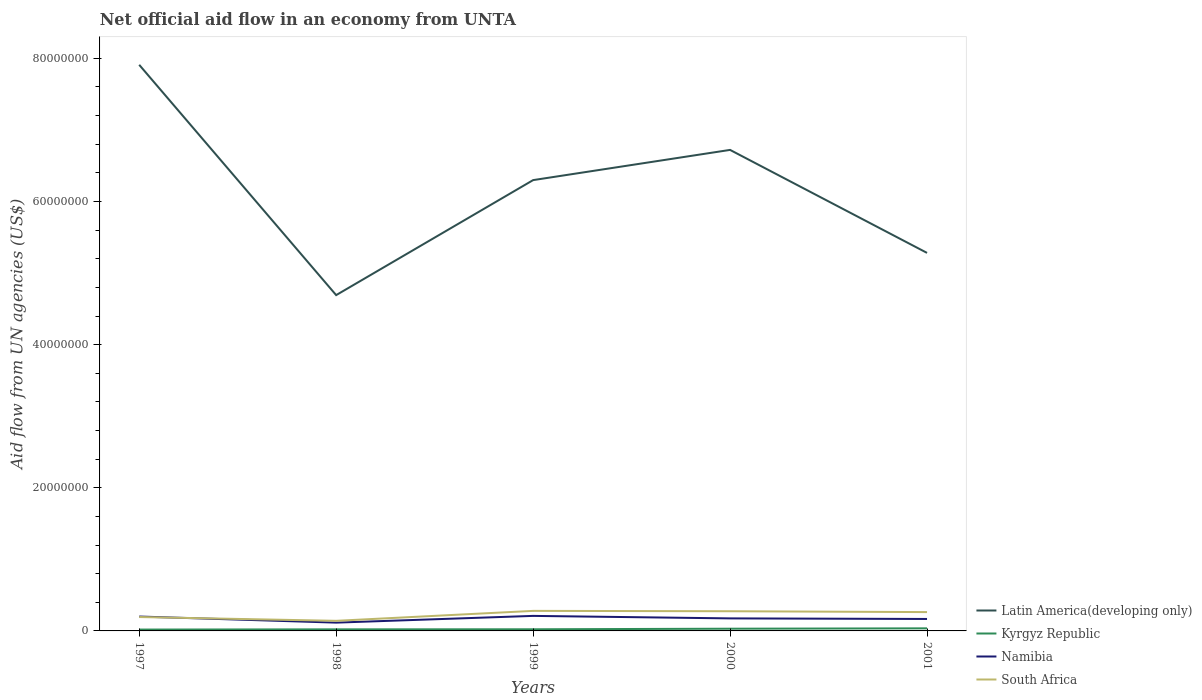Is the number of lines equal to the number of legend labels?
Give a very brief answer. Yes. Across all years, what is the maximum net official aid flow in Latin America(developing only)?
Make the answer very short. 4.69e+07. In which year was the net official aid flow in Kyrgyz Republic maximum?
Offer a very short reply. 1997. What is the total net official aid flow in Latin America(developing only) in the graph?
Keep it short and to the point. 1.61e+07. What is the difference between the highest and the second highest net official aid flow in Latin America(developing only)?
Provide a succinct answer. 3.22e+07. How many lines are there?
Ensure brevity in your answer.  4. Are the values on the major ticks of Y-axis written in scientific E-notation?
Keep it short and to the point. No. Where does the legend appear in the graph?
Your answer should be very brief. Bottom right. How are the legend labels stacked?
Provide a succinct answer. Vertical. What is the title of the graph?
Offer a terse response. Net official aid flow in an economy from UNTA. Does "Tajikistan" appear as one of the legend labels in the graph?
Your answer should be very brief. No. What is the label or title of the X-axis?
Your answer should be compact. Years. What is the label or title of the Y-axis?
Provide a short and direct response. Aid flow from UN agencies (US$). What is the Aid flow from UN agencies (US$) in Latin America(developing only) in 1997?
Ensure brevity in your answer.  7.91e+07. What is the Aid flow from UN agencies (US$) in Namibia in 1997?
Give a very brief answer. 2.01e+06. What is the Aid flow from UN agencies (US$) of South Africa in 1997?
Keep it short and to the point. 1.94e+06. What is the Aid flow from UN agencies (US$) in Latin America(developing only) in 1998?
Keep it short and to the point. 4.69e+07. What is the Aid flow from UN agencies (US$) of Kyrgyz Republic in 1998?
Keep it short and to the point. 2.20e+05. What is the Aid flow from UN agencies (US$) of Namibia in 1998?
Your response must be concise. 1.16e+06. What is the Aid flow from UN agencies (US$) of South Africa in 1998?
Provide a succinct answer. 1.41e+06. What is the Aid flow from UN agencies (US$) of Latin America(developing only) in 1999?
Your response must be concise. 6.30e+07. What is the Aid flow from UN agencies (US$) of Namibia in 1999?
Your response must be concise. 2.10e+06. What is the Aid flow from UN agencies (US$) of South Africa in 1999?
Offer a very short reply. 2.80e+06. What is the Aid flow from UN agencies (US$) of Latin America(developing only) in 2000?
Your answer should be compact. 6.72e+07. What is the Aid flow from UN agencies (US$) in Kyrgyz Republic in 2000?
Keep it short and to the point. 3.10e+05. What is the Aid flow from UN agencies (US$) in Namibia in 2000?
Provide a short and direct response. 1.75e+06. What is the Aid flow from UN agencies (US$) in South Africa in 2000?
Ensure brevity in your answer.  2.75e+06. What is the Aid flow from UN agencies (US$) in Latin America(developing only) in 2001?
Offer a very short reply. 5.28e+07. What is the Aid flow from UN agencies (US$) of Kyrgyz Republic in 2001?
Offer a terse response. 3.60e+05. What is the Aid flow from UN agencies (US$) in Namibia in 2001?
Make the answer very short. 1.67e+06. What is the Aid flow from UN agencies (US$) in South Africa in 2001?
Provide a short and direct response. 2.63e+06. Across all years, what is the maximum Aid flow from UN agencies (US$) in Latin America(developing only)?
Give a very brief answer. 7.91e+07. Across all years, what is the maximum Aid flow from UN agencies (US$) of Kyrgyz Republic?
Offer a terse response. 3.60e+05. Across all years, what is the maximum Aid flow from UN agencies (US$) in Namibia?
Offer a very short reply. 2.10e+06. Across all years, what is the maximum Aid flow from UN agencies (US$) of South Africa?
Keep it short and to the point. 2.80e+06. Across all years, what is the minimum Aid flow from UN agencies (US$) in Latin America(developing only)?
Offer a terse response. 4.69e+07. Across all years, what is the minimum Aid flow from UN agencies (US$) of Kyrgyz Republic?
Your answer should be very brief. 1.90e+05. Across all years, what is the minimum Aid flow from UN agencies (US$) in Namibia?
Make the answer very short. 1.16e+06. Across all years, what is the minimum Aid flow from UN agencies (US$) of South Africa?
Ensure brevity in your answer.  1.41e+06. What is the total Aid flow from UN agencies (US$) in Latin America(developing only) in the graph?
Make the answer very short. 3.09e+08. What is the total Aid flow from UN agencies (US$) of Kyrgyz Republic in the graph?
Your answer should be compact. 1.31e+06. What is the total Aid flow from UN agencies (US$) of Namibia in the graph?
Your answer should be compact. 8.69e+06. What is the total Aid flow from UN agencies (US$) of South Africa in the graph?
Offer a terse response. 1.15e+07. What is the difference between the Aid flow from UN agencies (US$) in Latin America(developing only) in 1997 and that in 1998?
Your response must be concise. 3.22e+07. What is the difference between the Aid flow from UN agencies (US$) in Namibia in 1997 and that in 1998?
Your answer should be very brief. 8.50e+05. What is the difference between the Aid flow from UN agencies (US$) of South Africa in 1997 and that in 1998?
Keep it short and to the point. 5.30e+05. What is the difference between the Aid flow from UN agencies (US$) in Latin America(developing only) in 1997 and that in 1999?
Provide a short and direct response. 1.61e+07. What is the difference between the Aid flow from UN agencies (US$) of Kyrgyz Republic in 1997 and that in 1999?
Keep it short and to the point. -4.00e+04. What is the difference between the Aid flow from UN agencies (US$) in Namibia in 1997 and that in 1999?
Your answer should be very brief. -9.00e+04. What is the difference between the Aid flow from UN agencies (US$) of South Africa in 1997 and that in 1999?
Your answer should be compact. -8.60e+05. What is the difference between the Aid flow from UN agencies (US$) of Latin America(developing only) in 1997 and that in 2000?
Make the answer very short. 1.19e+07. What is the difference between the Aid flow from UN agencies (US$) in Kyrgyz Republic in 1997 and that in 2000?
Offer a terse response. -1.20e+05. What is the difference between the Aid flow from UN agencies (US$) of Namibia in 1997 and that in 2000?
Keep it short and to the point. 2.60e+05. What is the difference between the Aid flow from UN agencies (US$) in South Africa in 1997 and that in 2000?
Make the answer very short. -8.10e+05. What is the difference between the Aid flow from UN agencies (US$) of Latin America(developing only) in 1997 and that in 2001?
Offer a very short reply. 2.63e+07. What is the difference between the Aid flow from UN agencies (US$) in Namibia in 1997 and that in 2001?
Your response must be concise. 3.40e+05. What is the difference between the Aid flow from UN agencies (US$) of South Africa in 1997 and that in 2001?
Make the answer very short. -6.90e+05. What is the difference between the Aid flow from UN agencies (US$) in Latin America(developing only) in 1998 and that in 1999?
Offer a very short reply. -1.61e+07. What is the difference between the Aid flow from UN agencies (US$) in Namibia in 1998 and that in 1999?
Keep it short and to the point. -9.40e+05. What is the difference between the Aid flow from UN agencies (US$) of South Africa in 1998 and that in 1999?
Your answer should be very brief. -1.39e+06. What is the difference between the Aid flow from UN agencies (US$) in Latin America(developing only) in 1998 and that in 2000?
Make the answer very short. -2.03e+07. What is the difference between the Aid flow from UN agencies (US$) in Namibia in 1998 and that in 2000?
Provide a succinct answer. -5.90e+05. What is the difference between the Aid flow from UN agencies (US$) in South Africa in 1998 and that in 2000?
Make the answer very short. -1.34e+06. What is the difference between the Aid flow from UN agencies (US$) in Latin America(developing only) in 1998 and that in 2001?
Your response must be concise. -5.90e+06. What is the difference between the Aid flow from UN agencies (US$) of Kyrgyz Republic in 1998 and that in 2001?
Your answer should be very brief. -1.40e+05. What is the difference between the Aid flow from UN agencies (US$) in Namibia in 1998 and that in 2001?
Your answer should be compact. -5.10e+05. What is the difference between the Aid flow from UN agencies (US$) of South Africa in 1998 and that in 2001?
Offer a terse response. -1.22e+06. What is the difference between the Aid flow from UN agencies (US$) in Latin America(developing only) in 1999 and that in 2000?
Your answer should be compact. -4.22e+06. What is the difference between the Aid flow from UN agencies (US$) of Kyrgyz Republic in 1999 and that in 2000?
Your answer should be very brief. -8.00e+04. What is the difference between the Aid flow from UN agencies (US$) in Namibia in 1999 and that in 2000?
Give a very brief answer. 3.50e+05. What is the difference between the Aid flow from UN agencies (US$) of Latin America(developing only) in 1999 and that in 2001?
Provide a succinct answer. 1.02e+07. What is the difference between the Aid flow from UN agencies (US$) of Kyrgyz Republic in 1999 and that in 2001?
Your answer should be very brief. -1.30e+05. What is the difference between the Aid flow from UN agencies (US$) in Latin America(developing only) in 2000 and that in 2001?
Your response must be concise. 1.44e+07. What is the difference between the Aid flow from UN agencies (US$) in Kyrgyz Republic in 2000 and that in 2001?
Provide a succinct answer. -5.00e+04. What is the difference between the Aid flow from UN agencies (US$) of South Africa in 2000 and that in 2001?
Your answer should be very brief. 1.20e+05. What is the difference between the Aid flow from UN agencies (US$) of Latin America(developing only) in 1997 and the Aid flow from UN agencies (US$) of Kyrgyz Republic in 1998?
Provide a short and direct response. 7.89e+07. What is the difference between the Aid flow from UN agencies (US$) in Latin America(developing only) in 1997 and the Aid flow from UN agencies (US$) in Namibia in 1998?
Give a very brief answer. 7.79e+07. What is the difference between the Aid flow from UN agencies (US$) in Latin America(developing only) in 1997 and the Aid flow from UN agencies (US$) in South Africa in 1998?
Keep it short and to the point. 7.77e+07. What is the difference between the Aid flow from UN agencies (US$) in Kyrgyz Republic in 1997 and the Aid flow from UN agencies (US$) in Namibia in 1998?
Keep it short and to the point. -9.70e+05. What is the difference between the Aid flow from UN agencies (US$) in Kyrgyz Republic in 1997 and the Aid flow from UN agencies (US$) in South Africa in 1998?
Offer a very short reply. -1.22e+06. What is the difference between the Aid flow from UN agencies (US$) in Namibia in 1997 and the Aid flow from UN agencies (US$) in South Africa in 1998?
Provide a succinct answer. 6.00e+05. What is the difference between the Aid flow from UN agencies (US$) in Latin America(developing only) in 1997 and the Aid flow from UN agencies (US$) in Kyrgyz Republic in 1999?
Keep it short and to the point. 7.89e+07. What is the difference between the Aid flow from UN agencies (US$) in Latin America(developing only) in 1997 and the Aid flow from UN agencies (US$) in Namibia in 1999?
Make the answer very short. 7.70e+07. What is the difference between the Aid flow from UN agencies (US$) of Latin America(developing only) in 1997 and the Aid flow from UN agencies (US$) of South Africa in 1999?
Keep it short and to the point. 7.63e+07. What is the difference between the Aid flow from UN agencies (US$) of Kyrgyz Republic in 1997 and the Aid flow from UN agencies (US$) of Namibia in 1999?
Give a very brief answer. -1.91e+06. What is the difference between the Aid flow from UN agencies (US$) in Kyrgyz Republic in 1997 and the Aid flow from UN agencies (US$) in South Africa in 1999?
Make the answer very short. -2.61e+06. What is the difference between the Aid flow from UN agencies (US$) in Namibia in 1997 and the Aid flow from UN agencies (US$) in South Africa in 1999?
Offer a terse response. -7.90e+05. What is the difference between the Aid flow from UN agencies (US$) of Latin America(developing only) in 1997 and the Aid flow from UN agencies (US$) of Kyrgyz Republic in 2000?
Ensure brevity in your answer.  7.88e+07. What is the difference between the Aid flow from UN agencies (US$) in Latin America(developing only) in 1997 and the Aid flow from UN agencies (US$) in Namibia in 2000?
Your answer should be very brief. 7.74e+07. What is the difference between the Aid flow from UN agencies (US$) in Latin America(developing only) in 1997 and the Aid flow from UN agencies (US$) in South Africa in 2000?
Provide a short and direct response. 7.64e+07. What is the difference between the Aid flow from UN agencies (US$) in Kyrgyz Republic in 1997 and the Aid flow from UN agencies (US$) in Namibia in 2000?
Your answer should be very brief. -1.56e+06. What is the difference between the Aid flow from UN agencies (US$) in Kyrgyz Republic in 1997 and the Aid flow from UN agencies (US$) in South Africa in 2000?
Keep it short and to the point. -2.56e+06. What is the difference between the Aid flow from UN agencies (US$) in Namibia in 1997 and the Aid flow from UN agencies (US$) in South Africa in 2000?
Provide a short and direct response. -7.40e+05. What is the difference between the Aid flow from UN agencies (US$) in Latin America(developing only) in 1997 and the Aid flow from UN agencies (US$) in Kyrgyz Republic in 2001?
Your response must be concise. 7.87e+07. What is the difference between the Aid flow from UN agencies (US$) in Latin America(developing only) in 1997 and the Aid flow from UN agencies (US$) in Namibia in 2001?
Give a very brief answer. 7.74e+07. What is the difference between the Aid flow from UN agencies (US$) of Latin America(developing only) in 1997 and the Aid flow from UN agencies (US$) of South Africa in 2001?
Offer a terse response. 7.65e+07. What is the difference between the Aid flow from UN agencies (US$) of Kyrgyz Republic in 1997 and the Aid flow from UN agencies (US$) of Namibia in 2001?
Offer a terse response. -1.48e+06. What is the difference between the Aid flow from UN agencies (US$) in Kyrgyz Republic in 1997 and the Aid flow from UN agencies (US$) in South Africa in 2001?
Give a very brief answer. -2.44e+06. What is the difference between the Aid flow from UN agencies (US$) of Namibia in 1997 and the Aid flow from UN agencies (US$) of South Africa in 2001?
Your answer should be very brief. -6.20e+05. What is the difference between the Aid flow from UN agencies (US$) of Latin America(developing only) in 1998 and the Aid flow from UN agencies (US$) of Kyrgyz Republic in 1999?
Your answer should be very brief. 4.67e+07. What is the difference between the Aid flow from UN agencies (US$) in Latin America(developing only) in 1998 and the Aid flow from UN agencies (US$) in Namibia in 1999?
Ensure brevity in your answer.  4.48e+07. What is the difference between the Aid flow from UN agencies (US$) of Latin America(developing only) in 1998 and the Aid flow from UN agencies (US$) of South Africa in 1999?
Ensure brevity in your answer.  4.41e+07. What is the difference between the Aid flow from UN agencies (US$) of Kyrgyz Republic in 1998 and the Aid flow from UN agencies (US$) of Namibia in 1999?
Provide a succinct answer. -1.88e+06. What is the difference between the Aid flow from UN agencies (US$) of Kyrgyz Republic in 1998 and the Aid flow from UN agencies (US$) of South Africa in 1999?
Offer a very short reply. -2.58e+06. What is the difference between the Aid flow from UN agencies (US$) of Namibia in 1998 and the Aid flow from UN agencies (US$) of South Africa in 1999?
Your answer should be very brief. -1.64e+06. What is the difference between the Aid flow from UN agencies (US$) in Latin America(developing only) in 1998 and the Aid flow from UN agencies (US$) in Kyrgyz Republic in 2000?
Make the answer very short. 4.66e+07. What is the difference between the Aid flow from UN agencies (US$) in Latin America(developing only) in 1998 and the Aid flow from UN agencies (US$) in Namibia in 2000?
Your response must be concise. 4.52e+07. What is the difference between the Aid flow from UN agencies (US$) in Latin America(developing only) in 1998 and the Aid flow from UN agencies (US$) in South Africa in 2000?
Provide a short and direct response. 4.42e+07. What is the difference between the Aid flow from UN agencies (US$) in Kyrgyz Republic in 1998 and the Aid flow from UN agencies (US$) in Namibia in 2000?
Ensure brevity in your answer.  -1.53e+06. What is the difference between the Aid flow from UN agencies (US$) in Kyrgyz Republic in 1998 and the Aid flow from UN agencies (US$) in South Africa in 2000?
Your answer should be compact. -2.53e+06. What is the difference between the Aid flow from UN agencies (US$) of Namibia in 1998 and the Aid flow from UN agencies (US$) of South Africa in 2000?
Offer a very short reply. -1.59e+06. What is the difference between the Aid flow from UN agencies (US$) in Latin America(developing only) in 1998 and the Aid flow from UN agencies (US$) in Kyrgyz Republic in 2001?
Provide a short and direct response. 4.66e+07. What is the difference between the Aid flow from UN agencies (US$) in Latin America(developing only) in 1998 and the Aid flow from UN agencies (US$) in Namibia in 2001?
Make the answer very short. 4.52e+07. What is the difference between the Aid flow from UN agencies (US$) in Latin America(developing only) in 1998 and the Aid flow from UN agencies (US$) in South Africa in 2001?
Your answer should be compact. 4.43e+07. What is the difference between the Aid flow from UN agencies (US$) in Kyrgyz Republic in 1998 and the Aid flow from UN agencies (US$) in Namibia in 2001?
Your response must be concise. -1.45e+06. What is the difference between the Aid flow from UN agencies (US$) of Kyrgyz Republic in 1998 and the Aid flow from UN agencies (US$) of South Africa in 2001?
Offer a terse response. -2.41e+06. What is the difference between the Aid flow from UN agencies (US$) in Namibia in 1998 and the Aid flow from UN agencies (US$) in South Africa in 2001?
Your response must be concise. -1.47e+06. What is the difference between the Aid flow from UN agencies (US$) of Latin America(developing only) in 1999 and the Aid flow from UN agencies (US$) of Kyrgyz Republic in 2000?
Your answer should be compact. 6.27e+07. What is the difference between the Aid flow from UN agencies (US$) of Latin America(developing only) in 1999 and the Aid flow from UN agencies (US$) of Namibia in 2000?
Provide a succinct answer. 6.12e+07. What is the difference between the Aid flow from UN agencies (US$) in Latin America(developing only) in 1999 and the Aid flow from UN agencies (US$) in South Africa in 2000?
Ensure brevity in your answer.  6.02e+07. What is the difference between the Aid flow from UN agencies (US$) of Kyrgyz Republic in 1999 and the Aid flow from UN agencies (US$) of Namibia in 2000?
Provide a succinct answer. -1.52e+06. What is the difference between the Aid flow from UN agencies (US$) of Kyrgyz Republic in 1999 and the Aid flow from UN agencies (US$) of South Africa in 2000?
Your answer should be very brief. -2.52e+06. What is the difference between the Aid flow from UN agencies (US$) of Namibia in 1999 and the Aid flow from UN agencies (US$) of South Africa in 2000?
Offer a very short reply. -6.50e+05. What is the difference between the Aid flow from UN agencies (US$) of Latin America(developing only) in 1999 and the Aid flow from UN agencies (US$) of Kyrgyz Republic in 2001?
Make the answer very short. 6.26e+07. What is the difference between the Aid flow from UN agencies (US$) in Latin America(developing only) in 1999 and the Aid flow from UN agencies (US$) in Namibia in 2001?
Offer a terse response. 6.13e+07. What is the difference between the Aid flow from UN agencies (US$) in Latin America(developing only) in 1999 and the Aid flow from UN agencies (US$) in South Africa in 2001?
Your answer should be very brief. 6.04e+07. What is the difference between the Aid flow from UN agencies (US$) of Kyrgyz Republic in 1999 and the Aid flow from UN agencies (US$) of Namibia in 2001?
Your response must be concise. -1.44e+06. What is the difference between the Aid flow from UN agencies (US$) of Kyrgyz Republic in 1999 and the Aid flow from UN agencies (US$) of South Africa in 2001?
Make the answer very short. -2.40e+06. What is the difference between the Aid flow from UN agencies (US$) of Namibia in 1999 and the Aid flow from UN agencies (US$) of South Africa in 2001?
Your answer should be very brief. -5.30e+05. What is the difference between the Aid flow from UN agencies (US$) in Latin America(developing only) in 2000 and the Aid flow from UN agencies (US$) in Kyrgyz Republic in 2001?
Your response must be concise. 6.68e+07. What is the difference between the Aid flow from UN agencies (US$) in Latin America(developing only) in 2000 and the Aid flow from UN agencies (US$) in Namibia in 2001?
Your answer should be compact. 6.55e+07. What is the difference between the Aid flow from UN agencies (US$) of Latin America(developing only) in 2000 and the Aid flow from UN agencies (US$) of South Africa in 2001?
Provide a succinct answer. 6.46e+07. What is the difference between the Aid flow from UN agencies (US$) of Kyrgyz Republic in 2000 and the Aid flow from UN agencies (US$) of Namibia in 2001?
Offer a very short reply. -1.36e+06. What is the difference between the Aid flow from UN agencies (US$) of Kyrgyz Republic in 2000 and the Aid flow from UN agencies (US$) of South Africa in 2001?
Offer a terse response. -2.32e+06. What is the difference between the Aid flow from UN agencies (US$) in Namibia in 2000 and the Aid flow from UN agencies (US$) in South Africa in 2001?
Offer a very short reply. -8.80e+05. What is the average Aid flow from UN agencies (US$) in Latin America(developing only) per year?
Provide a succinct answer. 6.18e+07. What is the average Aid flow from UN agencies (US$) of Kyrgyz Republic per year?
Offer a very short reply. 2.62e+05. What is the average Aid flow from UN agencies (US$) in Namibia per year?
Offer a very short reply. 1.74e+06. What is the average Aid flow from UN agencies (US$) of South Africa per year?
Your answer should be very brief. 2.31e+06. In the year 1997, what is the difference between the Aid flow from UN agencies (US$) in Latin America(developing only) and Aid flow from UN agencies (US$) in Kyrgyz Republic?
Make the answer very short. 7.89e+07. In the year 1997, what is the difference between the Aid flow from UN agencies (US$) in Latin America(developing only) and Aid flow from UN agencies (US$) in Namibia?
Your response must be concise. 7.71e+07. In the year 1997, what is the difference between the Aid flow from UN agencies (US$) in Latin America(developing only) and Aid flow from UN agencies (US$) in South Africa?
Provide a succinct answer. 7.72e+07. In the year 1997, what is the difference between the Aid flow from UN agencies (US$) of Kyrgyz Republic and Aid flow from UN agencies (US$) of Namibia?
Offer a terse response. -1.82e+06. In the year 1997, what is the difference between the Aid flow from UN agencies (US$) in Kyrgyz Republic and Aid flow from UN agencies (US$) in South Africa?
Make the answer very short. -1.75e+06. In the year 1997, what is the difference between the Aid flow from UN agencies (US$) in Namibia and Aid flow from UN agencies (US$) in South Africa?
Provide a succinct answer. 7.00e+04. In the year 1998, what is the difference between the Aid flow from UN agencies (US$) of Latin America(developing only) and Aid flow from UN agencies (US$) of Kyrgyz Republic?
Provide a succinct answer. 4.67e+07. In the year 1998, what is the difference between the Aid flow from UN agencies (US$) of Latin America(developing only) and Aid flow from UN agencies (US$) of Namibia?
Provide a short and direct response. 4.58e+07. In the year 1998, what is the difference between the Aid flow from UN agencies (US$) in Latin America(developing only) and Aid flow from UN agencies (US$) in South Africa?
Provide a succinct answer. 4.55e+07. In the year 1998, what is the difference between the Aid flow from UN agencies (US$) in Kyrgyz Republic and Aid flow from UN agencies (US$) in Namibia?
Ensure brevity in your answer.  -9.40e+05. In the year 1998, what is the difference between the Aid flow from UN agencies (US$) of Kyrgyz Republic and Aid flow from UN agencies (US$) of South Africa?
Keep it short and to the point. -1.19e+06. In the year 1998, what is the difference between the Aid flow from UN agencies (US$) in Namibia and Aid flow from UN agencies (US$) in South Africa?
Your response must be concise. -2.50e+05. In the year 1999, what is the difference between the Aid flow from UN agencies (US$) in Latin America(developing only) and Aid flow from UN agencies (US$) in Kyrgyz Republic?
Provide a succinct answer. 6.28e+07. In the year 1999, what is the difference between the Aid flow from UN agencies (US$) in Latin America(developing only) and Aid flow from UN agencies (US$) in Namibia?
Your response must be concise. 6.09e+07. In the year 1999, what is the difference between the Aid flow from UN agencies (US$) in Latin America(developing only) and Aid flow from UN agencies (US$) in South Africa?
Provide a short and direct response. 6.02e+07. In the year 1999, what is the difference between the Aid flow from UN agencies (US$) of Kyrgyz Republic and Aid flow from UN agencies (US$) of Namibia?
Your answer should be compact. -1.87e+06. In the year 1999, what is the difference between the Aid flow from UN agencies (US$) of Kyrgyz Republic and Aid flow from UN agencies (US$) of South Africa?
Keep it short and to the point. -2.57e+06. In the year 1999, what is the difference between the Aid flow from UN agencies (US$) of Namibia and Aid flow from UN agencies (US$) of South Africa?
Make the answer very short. -7.00e+05. In the year 2000, what is the difference between the Aid flow from UN agencies (US$) of Latin America(developing only) and Aid flow from UN agencies (US$) of Kyrgyz Republic?
Your answer should be compact. 6.69e+07. In the year 2000, what is the difference between the Aid flow from UN agencies (US$) in Latin America(developing only) and Aid flow from UN agencies (US$) in Namibia?
Your answer should be compact. 6.55e+07. In the year 2000, what is the difference between the Aid flow from UN agencies (US$) of Latin America(developing only) and Aid flow from UN agencies (US$) of South Africa?
Provide a succinct answer. 6.45e+07. In the year 2000, what is the difference between the Aid flow from UN agencies (US$) in Kyrgyz Republic and Aid flow from UN agencies (US$) in Namibia?
Give a very brief answer. -1.44e+06. In the year 2000, what is the difference between the Aid flow from UN agencies (US$) of Kyrgyz Republic and Aid flow from UN agencies (US$) of South Africa?
Offer a very short reply. -2.44e+06. In the year 2000, what is the difference between the Aid flow from UN agencies (US$) in Namibia and Aid flow from UN agencies (US$) in South Africa?
Keep it short and to the point. -1.00e+06. In the year 2001, what is the difference between the Aid flow from UN agencies (US$) in Latin America(developing only) and Aid flow from UN agencies (US$) in Kyrgyz Republic?
Your answer should be very brief. 5.25e+07. In the year 2001, what is the difference between the Aid flow from UN agencies (US$) of Latin America(developing only) and Aid flow from UN agencies (US$) of Namibia?
Offer a terse response. 5.12e+07. In the year 2001, what is the difference between the Aid flow from UN agencies (US$) of Latin America(developing only) and Aid flow from UN agencies (US$) of South Africa?
Your answer should be very brief. 5.02e+07. In the year 2001, what is the difference between the Aid flow from UN agencies (US$) of Kyrgyz Republic and Aid flow from UN agencies (US$) of Namibia?
Offer a terse response. -1.31e+06. In the year 2001, what is the difference between the Aid flow from UN agencies (US$) in Kyrgyz Republic and Aid flow from UN agencies (US$) in South Africa?
Ensure brevity in your answer.  -2.27e+06. In the year 2001, what is the difference between the Aid flow from UN agencies (US$) of Namibia and Aid flow from UN agencies (US$) of South Africa?
Make the answer very short. -9.60e+05. What is the ratio of the Aid flow from UN agencies (US$) of Latin America(developing only) in 1997 to that in 1998?
Ensure brevity in your answer.  1.69. What is the ratio of the Aid flow from UN agencies (US$) of Kyrgyz Republic in 1997 to that in 1998?
Give a very brief answer. 0.86. What is the ratio of the Aid flow from UN agencies (US$) of Namibia in 1997 to that in 1998?
Ensure brevity in your answer.  1.73. What is the ratio of the Aid flow from UN agencies (US$) in South Africa in 1997 to that in 1998?
Provide a short and direct response. 1.38. What is the ratio of the Aid flow from UN agencies (US$) of Latin America(developing only) in 1997 to that in 1999?
Your answer should be compact. 1.26. What is the ratio of the Aid flow from UN agencies (US$) of Kyrgyz Republic in 1997 to that in 1999?
Offer a terse response. 0.83. What is the ratio of the Aid flow from UN agencies (US$) of Namibia in 1997 to that in 1999?
Keep it short and to the point. 0.96. What is the ratio of the Aid flow from UN agencies (US$) in South Africa in 1997 to that in 1999?
Make the answer very short. 0.69. What is the ratio of the Aid flow from UN agencies (US$) in Latin America(developing only) in 1997 to that in 2000?
Provide a short and direct response. 1.18. What is the ratio of the Aid flow from UN agencies (US$) of Kyrgyz Republic in 1997 to that in 2000?
Ensure brevity in your answer.  0.61. What is the ratio of the Aid flow from UN agencies (US$) in Namibia in 1997 to that in 2000?
Your response must be concise. 1.15. What is the ratio of the Aid flow from UN agencies (US$) of South Africa in 1997 to that in 2000?
Your response must be concise. 0.71. What is the ratio of the Aid flow from UN agencies (US$) of Latin America(developing only) in 1997 to that in 2001?
Your answer should be compact. 1.5. What is the ratio of the Aid flow from UN agencies (US$) of Kyrgyz Republic in 1997 to that in 2001?
Make the answer very short. 0.53. What is the ratio of the Aid flow from UN agencies (US$) in Namibia in 1997 to that in 2001?
Your answer should be compact. 1.2. What is the ratio of the Aid flow from UN agencies (US$) in South Africa in 1997 to that in 2001?
Give a very brief answer. 0.74. What is the ratio of the Aid flow from UN agencies (US$) in Latin America(developing only) in 1998 to that in 1999?
Provide a succinct answer. 0.74. What is the ratio of the Aid flow from UN agencies (US$) in Kyrgyz Republic in 1998 to that in 1999?
Your answer should be compact. 0.96. What is the ratio of the Aid flow from UN agencies (US$) of Namibia in 1998 to that in 1999?
Your response must be concise. 0.55. What is the ratio of the Aid flow from UN agencies (US$) in South Africa in 1998 to that in 1999?
Provide a short and direct response. 0.5. What is the ratio of the Aid flow from UN agencies (US$) in Latin America(developing only) in 1998 to that in 2000?
Your response must be concise. 0.7. What is the ratio of the Aid flow from UN agencies (US$) in Kyrgyz Republic in 1998 to that in 2000?
Ensure brevity in your answer.  0.71. What is the ratio of the Aid flow from UN agencies (US$) in Namibia in 1998 to that in 2000?
Your answer should be compact. 0.66. What is the ratio of the Aid flow from UN agencies (US$) of South Africa in 1998 to that in 2000?
Make the answer very short. 0.51. What is the ratio of the Aid flow from UN agencies (US$) in Latin America(developing only) in 1998 to that in 2001?
Offer a very short reply. 0.89. What is the ratio of the Aid flow from UN agencies (US$) in Kyrgyz Republic in 1998 to that in 2001?
Make the answer very short. 0.61. What is the ratio of the Aid flow from UN agencies (US$) in Namibia in 1998 to that in 2001?
Provide a succinct answer. 0.69. What is the ratio of the Aid flow from UN agencies (US$) in South Africa in 1998 to that in 2001?
Give a very brief answer. 0.54. What is the ratio of the Aid flow from UN agencies (US$) of Latin America(developing only) in 1999 to that in 2000?
Keep it short and to the point. 0.94. What is the ratio of the Aid flow from UN agencies (US$) of Kyrgyz Republic in 1999 to that in 2000?
Offer a terse response. 0.74. What is the ratio of the Aid flow from UN agencies (US$) in Namibia in 1999 to that in 2000?
Ensure brevity in your answer.  1.2. What is the ratio of the Aid flow from UN agencies (US$) of South Africa in 1999 to that in 2000?
Offer a terse response. 1.02. What is the ratio of the Aid flow from UN agencies (US$) of Latin America(developing only) in 1999 to that in 2001?
Your answer should be compact. 1.19. What is the ratio of the Aid flow from UN agencies (US$) of Kyrgyz Republic in 1999 to that in 2001?
Make the answer very short. 0.64. What is the ratio of the Aid flow from UN agencies (US$) of Namibia in 1999 to that in 2001?
Ensure brevity in your answer.  1.26. What is the ratio of the Aid flow from UN agencies (US$) in South Africa in 1999 to that in 2001?
Offer a terse response. 1.06. What is the ratio of the Aid flow from UN agencies (US$) in Latin America(developing only) in 2000 to that in 2001?
Keep it short and to the point. 1.27. What is the ratio of the Aid flow from UN agencies (US$) in Kyrgyz Republic in 2000 to that in 2001?
Offer a terse response. 0.86. What is the ratio of the Aid flow from UN agencies (US$) in Namibia in 2000 to that in 2001?
Provide a succinct answer. 1.05. What is the ratio of the Aid flow from UN agencies (US$) in South Africa in 2000 to that in 2001?
Your answer should be compact. 1.05. What is the difference between the highest and the second highest Aid flow from UN agencies (US$) in Latin America(developing only)?
Provide a succinct answer. 1.19e+07. What is the difference between the highest and the second highest Aid flow from UN agencies (US$) of Namibia?
Your answer should be very brief. 9.00e+04. What is the difference between the highest and the lowest Aid flow from UN agencies (US$) of Latin America(developing only)?
Provide a succinct answer. 3.22e+07. What is the difference between the highest and the lowest Aid flow from UN agencies (US$) in Kyrgyz Republic?
Offer a terse response. 1.70e+05. What is the difference between the highest and the lowest Aid flow from UN agencies (US$) of Namibia?
Make the answer very short. 9.40e+05. What is the difference between the highest and the lowest Aid flow from UN agencies (US$) in South Africa?
Provide a succinct answer. 1.39e+06. 